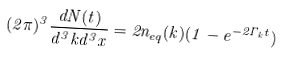<formula> <loc_0><loc_0><loc_500><loc_500>( 2 \pi ) ^ { 3 } \frac { d N ( t ) } { d ^ { 3 } k d ^ { 3 } x } = 2 n _ { e q } ( k ) ( 1 - e ^ { - 2 \Gamma _ { k } t } )</formula> 